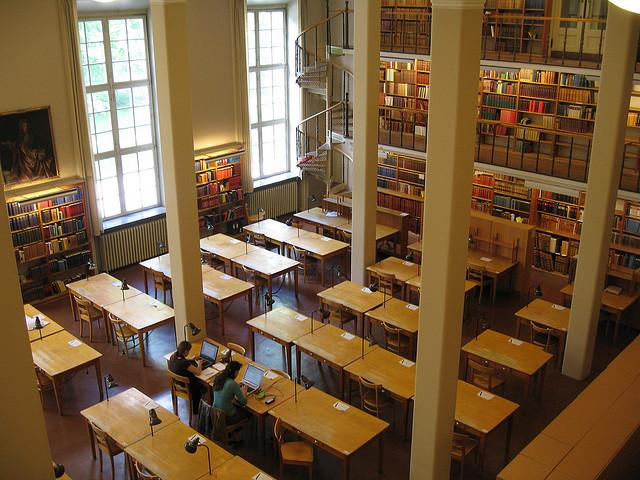What is located in the corner? Please explain your reasoning. stairs. There are ascending steps going in a circular fashion to the next floor. 